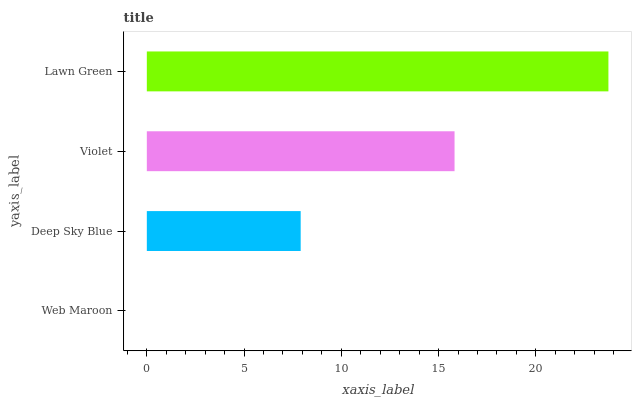Is Web Maroon the minimum?
Answer yes or no. Yes. Is Lawn Green the maximum?
Answer yes or no. Yes. Is Deep Sky Blue the minimum?
Answer yes or no. No. Is Deep Sky Blue the maximum?
Answer yes or no. No. Is Deep Sky Blue greater than Web Maroon?
Answer yes or no. Yes. Is Web Maroon less than Deep Sky Blue?
Answer yes or no. Yes. Is Web Maroon greater than Deep Sky Blue?
Answer yes or no. No. Is Deep Sky Blue less than Web Maroon?
Answer yes or no. No. Is Violet the high median?
Answer yes or no. Yes. Is Deep Sky Blue the low median?
Answer yes or no. Yes. Is Web Maroon the high median?
Answer yes or no. No. Is Lawn Green the low median?
Answer yes or no. No. 